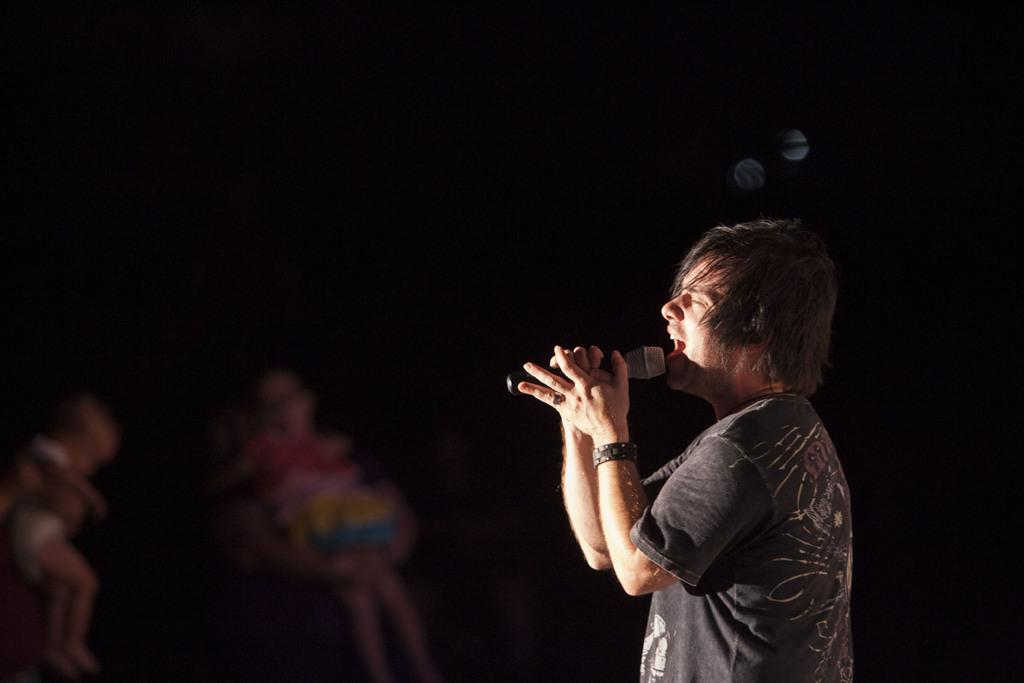What is the main subject of the image? There is a person in the image. What is the person doing in the image? The person is standing and singing. What object is the person holding in their hand? The person is holding a microphone in their hand. What is the person wearing in the image? The person is wearing a grey t-shirt. How many cherries are on the person's head in the image? There are no cherries present on the person's head in the image. What type of grain is visible in the background of the image? There is no grain visible in the background of the image. 